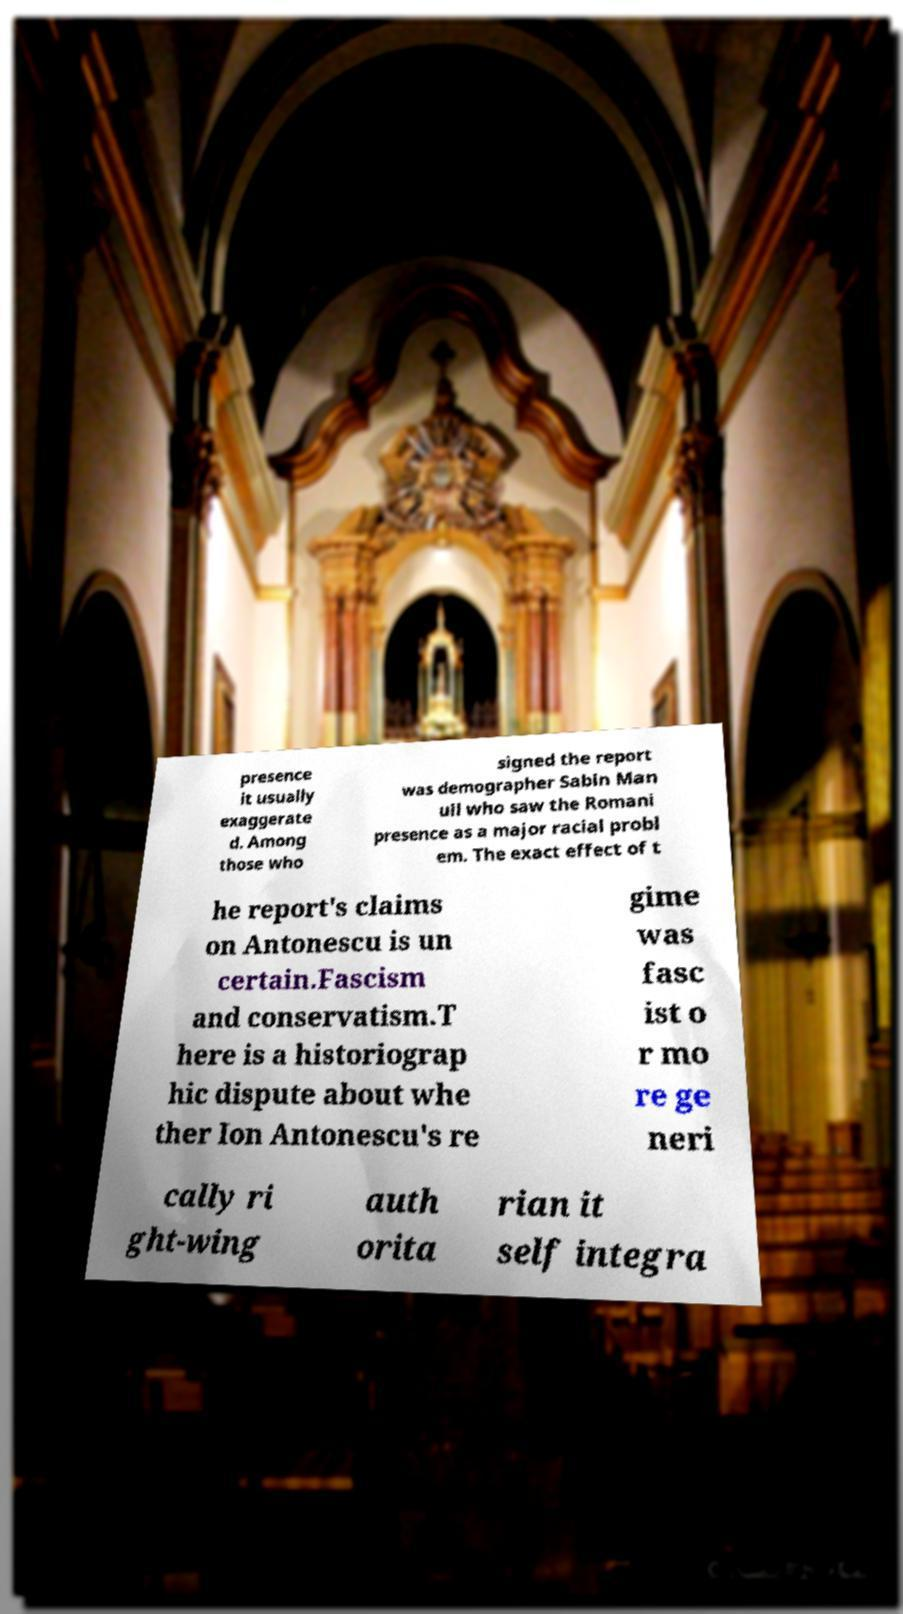Can you accurately transcribe the text from the provided image for me? presence it usually exaggerate d. Among those who signed the report was demographer Sabin Man uil who saw the Romani presence as a major racial probl em. The exact effect of t he report's claims on Antonescu is un certain.Fascism and conservatism.T here is a historiograp hic dispute about whe ther Ion Antonescu's re gime was fasc ist o r mo re ge neri cally ri ght-wing auth orita rian it self integra 